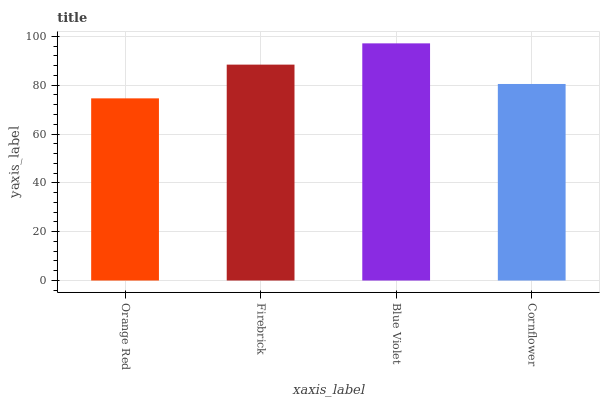Is Orange Red the minimum?
Answer yes or no. Yes. Is Blue Violet the maximum?
Answer yes or no. Yes. Is Firebrick the minimum?
Answer yes or no. No. Is Firebrick the maximum?
Answer yes or no. No. Is Firebrick greater than Orange Red?
Answer yes or no. Yes. Is Orange Red less than Firebrick?
Answer yes or no. Yes. Is Orange Red greater than Firebrick?
Answer yes or no. No. Is Firebrick less than Orange Red?
Answer yes or no. No. Is Firebrick the high median?
Answer yes or no. Yes. Is Cornflower the low median?
Answer yes or no. Yes. Is Cornflower the high median?
Answer yes or no. No. Is Orange Red the low median?
Answer yes or no. No. 